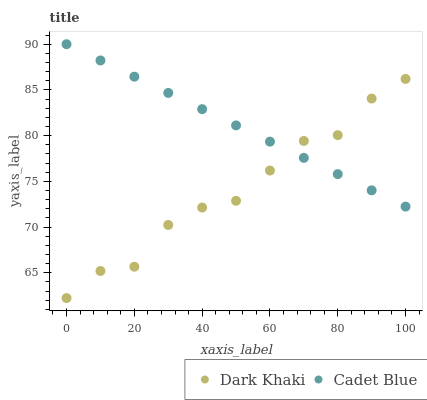Does Dark Khaki have the minimum area under the curve?
Answer yes or no. Yes. Does Cadet Blue have the maximum area under the curve?
Answer yes or no. Yes. Does Cadet Blue have the minimum area under the curve?
Answer yes or no. No. Is Cadet Blue the smoothest?
Answer yes or no. Yes. Is Dark Khaki the roughest?
Answer yes or no. Yes. Is Cadet Blue the roughest?
Answer yes or no. No. Does Dark Khaki have the lowest value?
Answer yes or no. Yes. Does Cadet Blue have the lowest value?
Answer yes or no. No. Does Cadet Blue have the highest value?
Answer yes or no. Yes. Does Cadet Blue intersect Dark Khaki?
Answer yes or no. Yes. Is Cadet Blue less than Dark Khaki?
Answer yes or no. No. Is Cadet Blue greater than Dark Khaki?
Answer yes or no. No. 